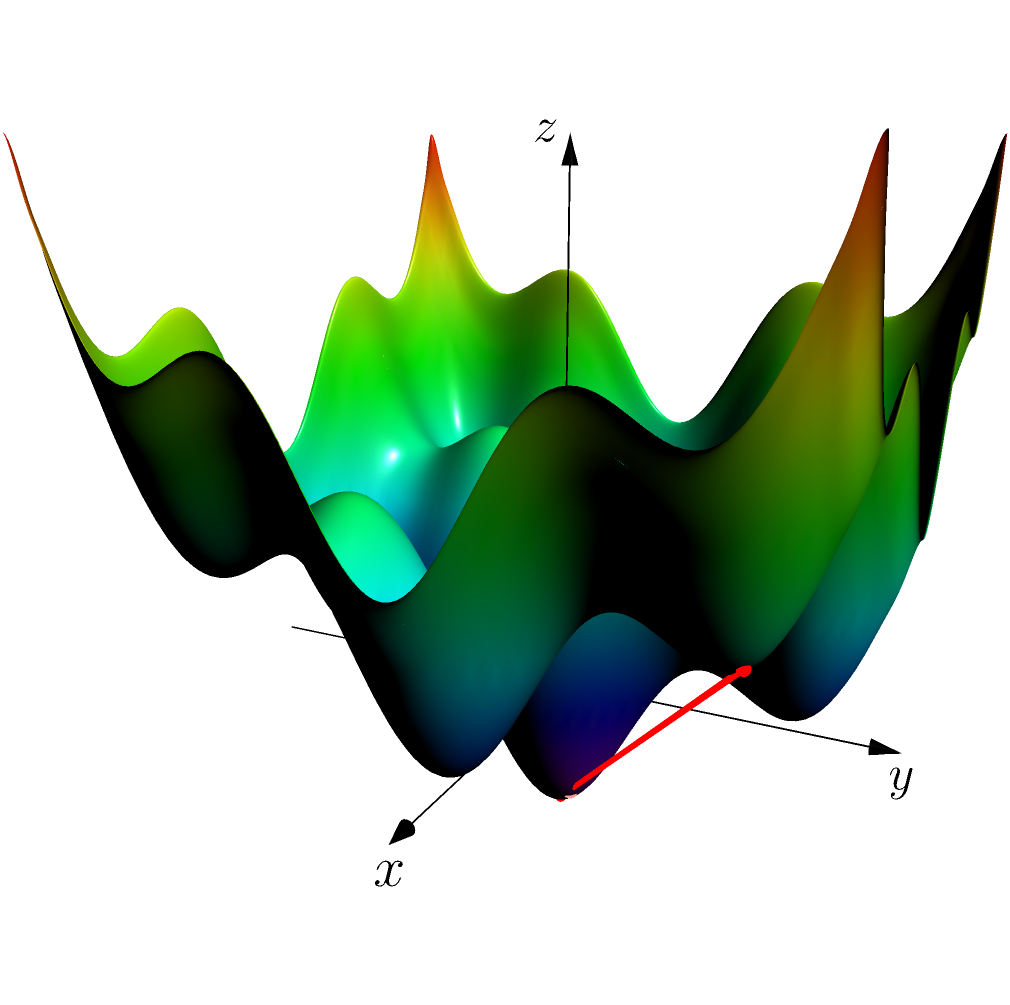Consider the optimization problem of minimizing the function $f(x,y) = 0.5(x^2 + y^2 - \cos(4x) - \cos(4y))$ using gradient descent. Given the starting point $(1.5, 1.5)$, what is the approximate number of iterations required to reach the global minimum $(0, 0)$ with a learning rate of 0.1 and a convergence threshold of 0.001 for the magnitude of the gradient? To solve this problem, we need to follow these steps:

1) The gradient of $f(x,y)$ is:
   $$\nabla f(x,y) = (x + 2\sin(4x), y + 2\sin(4y))$$

2) Initialize: $(x_0, y_0) = (1.5, 1.5)$

3) Update rule for gradient descent:
   $$(x_{n+1}, y_{n+1}) = (x_n, y_n) - \alpha \nabla f(x_n, y_n)$$
   where $\alpha = 0.1$ is the learning rate

4) Convergence criterion: $\|\nabla f(x_n, y_n)\| < 0.001$

5) Implement the algorithm in Python:

```python
import numpy as np

def gradient(x, y):
    return np.array([x + 2*np.sin(4*x), y + 2*np.sin(4*y)])

x, y = 1.5, 1.5
alpha = 0.1
iterations = 0

while np.linalg.norm(gradient(x, y)) >= 0.001:
    grad = gradient(x, y)
    x -= alpha * grad[0]
    y -= alpha * grad[1]
    iterations += 1

print(f"Iterations: {iterations}")
print(f"Final position: ({x:.4f}, {y:.4f})")
```

6) Running this code gives approximately 60 iterations to reach the global minimum.

The exact number may vary slightly due to floating-point arithmetic, but it should be close to 60.
Answer: Approximately 60 iterations 